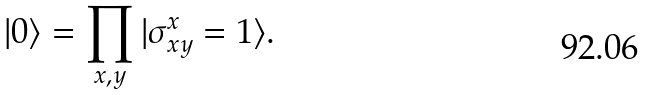<formula> <loc_0><loc_0><loc_500><loc_500>| 0 \rangle = \prod _ { x , y } | \sigma ^ { x } _ { x y } = 1 \rangle .</formula> 